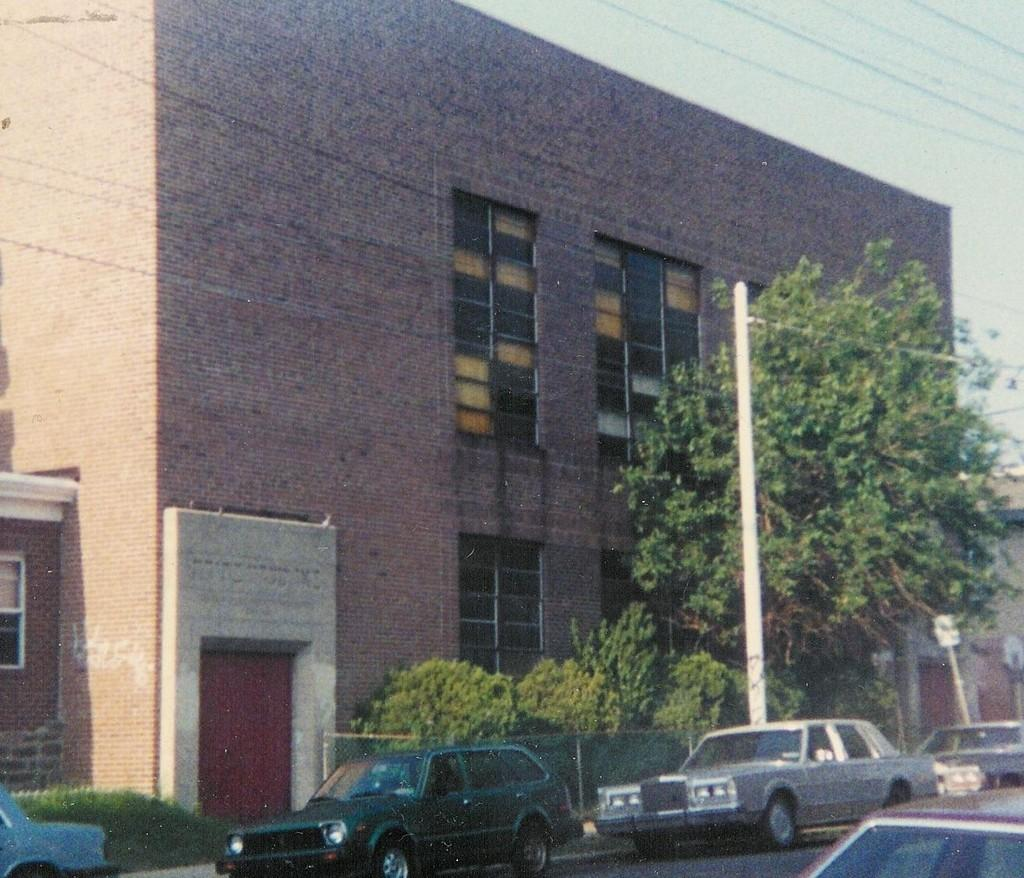What can be seen in the foreground of the image? In the foreground of the image, there are fleets of cars, trees, a fence, and a building on the road. What type of vegetation is present in the foreground? Trees are present in the foreground of the image. What is the purpose of the fence in the image? The purpose of the fence in the image is not explicitly stated, but it may be used to separate or enclose an area. What is visible in the top right corner of the image? The sky is visible in the top right corner of the image. Can you determine the time of day when the image was taken? Yes, the image was taken during the day, as indicated by the presence of sunlight and shadows. What type of shop can be seen in the image? There is no shop present in the image. How many clouds can be seen in the image? There are no clouds visible in the image; only the sky is visible in the top right corner. 